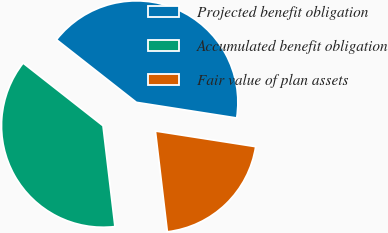<chart> <loc_0><loc_0><loc_500><loc_500><pie_chart><fcel>Projected benefit obligation<fcel>Accumulated benefit obligation<fcel>Fair value of plan assets<nl><fcel>41.87%<fcel>37.47%<fcel>20.66%<nl></chart> 